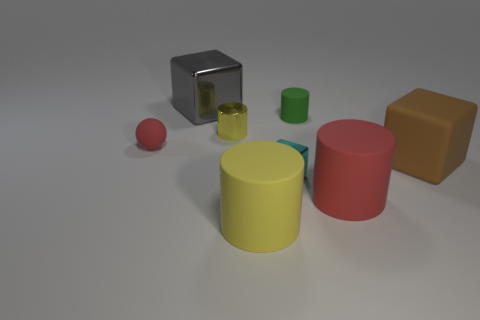Are there any big cylinders that have the same color as the small matte sphere?
Offer a terse response. Yes. Are there any large things that have the same shape as the small yellow metal object?
Provide a short and direct response. Yes. What shape is the matte thing that is the same color as the tiny sphere?
Give a very brief answer. Cylinder. What is the color of the large rubber object that is the same shape as the large gray metallic object?
Keep it short and to the point. Brown. How many things are tiny red objects or large blocks right of the small yellow cylinder?
Offer a terse response. 2. There is a metal thing that is behind the tiny red sphere and in front of the big gray shiny object; what is its shape?
Provide a short and direct response. Cylinder. What material is the block that is in front of the large cube that is in front of the gray shiny object?
Your answer should be very brief. Metal. Do the large block to the right of the small cyan block and the red ball have the same material?
Provide a short and direct response. Yes. How big is the red object left of the big gray metal cube?
Make the answer very short. Small. There is a red object right of the tiny matte ball; is there a large cylinder that is in front of it?
Your answer should be compact. Yes. 